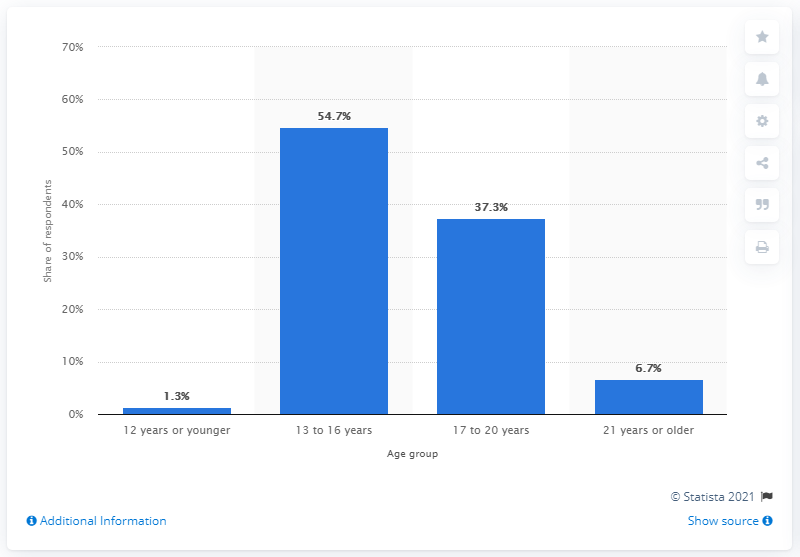List a handful of essential elements in this visual. According to the respondents, 54.7% of them stated that they were between 13 and 16 years old when they started working as a model. 